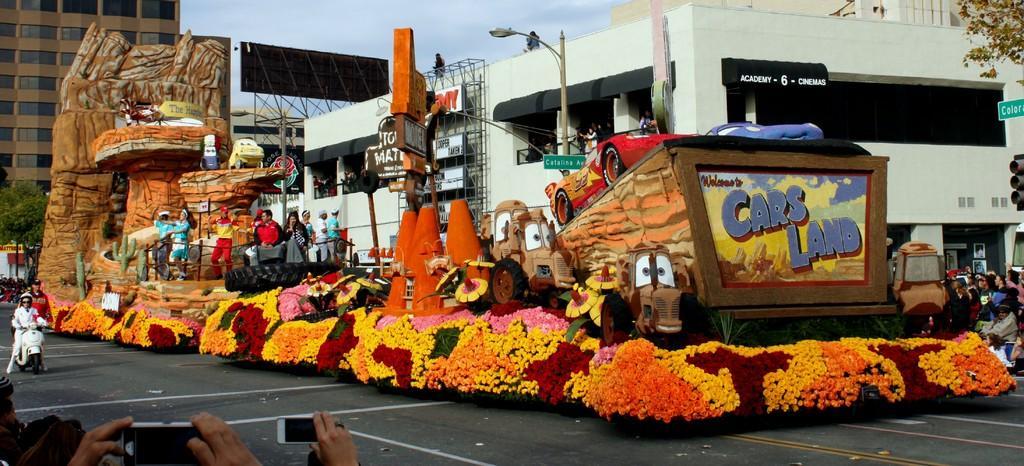Could you give a brief overview of what you see in this image? In this image I can see buildings ,street light pole, the sky and trees and a design and colorful vehicle visible on the road and on that vehicle I can see few persons,at the bottom I can see a person hand which is holding a mobile phone and I can see a person visible on bike on the left side and I can see a few persons visible on the right side. 